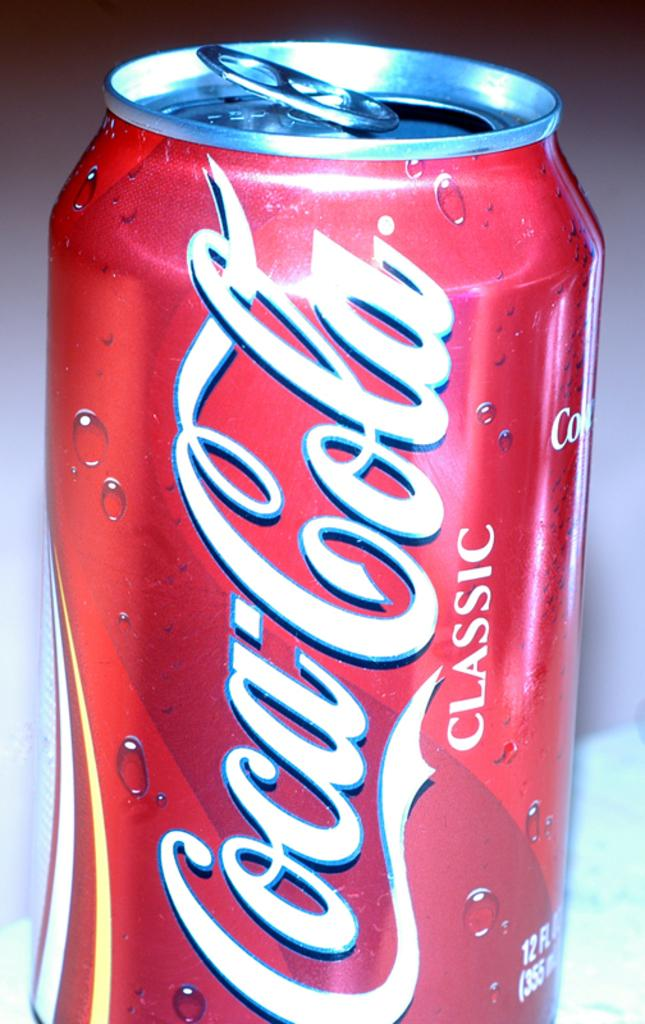<image>
Present a compact description of the photo's key features. A red can of Cocacola Classic is opened. 